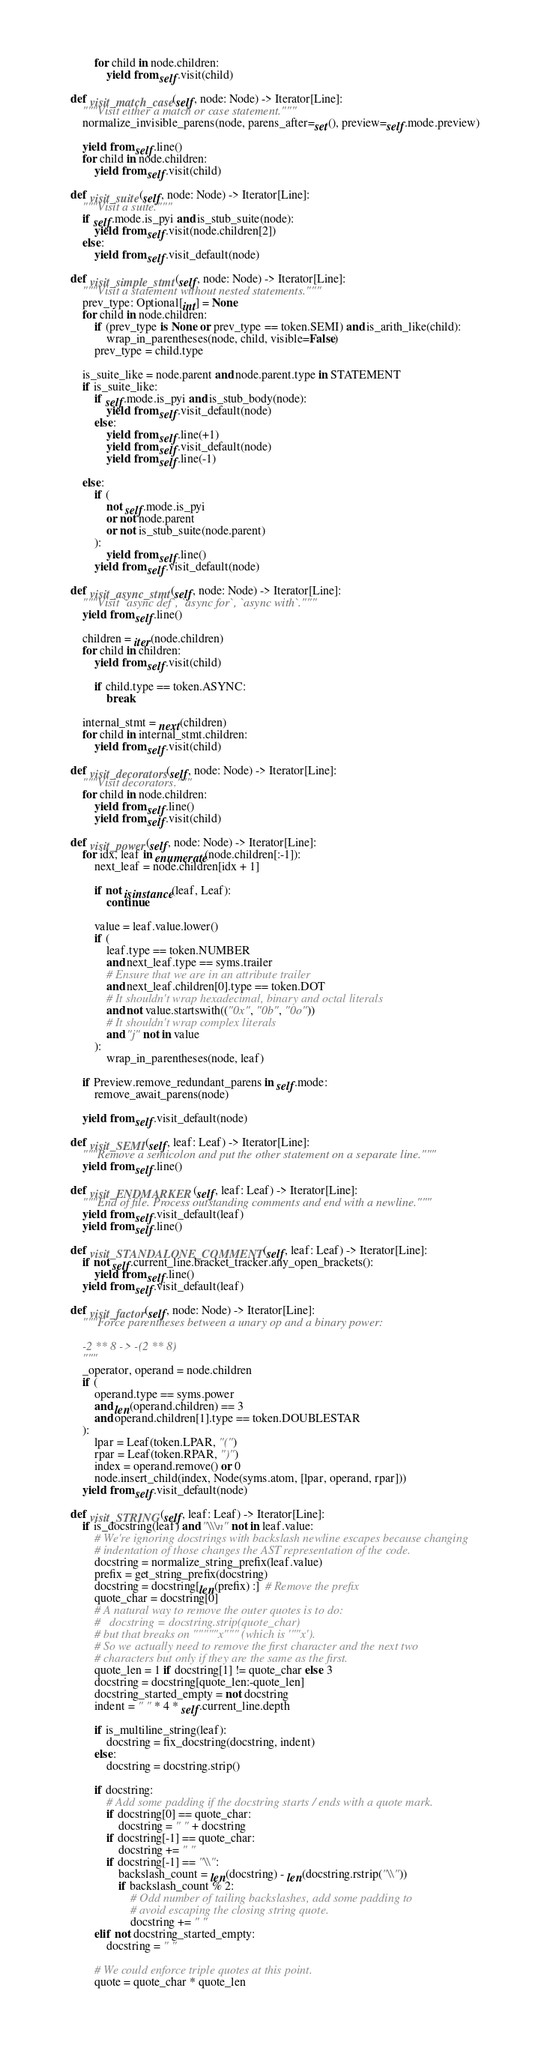Convert code to text. <code><loc_0><loc_0><loc_500><loc_500><_Python_>
            for child in node.children:
                yield from self.visit(child)

    def visit_match_case(self, node: Node) -> Iterator[Line]:
        """Visit either a match or case statement."""
        normalize_invisible_parens(node, parens_after=set(), preview=self.mode.preview)

        yield from self.line()
        for child in node.children:
            yield from self.visit(child)

    def visit_suite(self, node: Node) -> Iterator[Line]:
        """Visit a suite."""
        if self.mode.is_pyi and is_stub_suite(node):
            yield from self.visit(node.children[2])
        else:
            yield from self.visit_default(node)

    def visit_simple_stmt(self, node: Node) -> Iterator[Line]:
        """Visit a statement without nested statements."""
        prev_type: Optional[int] = None
        for child in node.children:
            if (prev_type is None or prev_type == token.SEMI) and is_arith_like(child):
                wrap_in_parentheses(node, child, visible=False)
            prev_type = child.type

        is_suite_like = node.parent and node.parent.type in STATEMENT
        if is_suite_like:
            if self.mode.is_pyi and is_stub_body(node):
                yield from self.visit_default(node)
            else:
                yield from self.line(+1)
                yield from self.visit_default(node)
                yield from self.line(-1)

        else:
            if (
                not self.mode.is_pyi
                or not node.parent
                or not is_stub_suite(node.parent)
            ):
                yield from self.line()
            yield from self.visit_default(node)

    def visit_async_stmt(self, node: Node) -> Iterator[Line]:
        """Visit `async def`, `async for`, `async with`."""
        yield from self.line()

        children = iter(node.children)
        for child in children:
            yield from self.visit(child)

            if child.type == token.ASYNC:
                break

        internal_stmt = next(children)
        for child in internal_stmt.children:
            yield from self.visit(child)

    def visit_decorators(self, node: Node) -> Iterator[Line]:
        """Visit decorators."""
        for child in node.children:
            yield from self.line()
            yield from self.visit(child)

    def visit_power(self, node: Node) -> Iterator[Line]:
        for idx, leaf in enumerate(node.children[:-1]):
            next_leaf = node.children[idx + 1]

            if not isinstance(leaf, Leaf):
                continue

            value = leaf.value.lower()
            if (
                leaf.type == token.NUMBER
                and next_leaf.type == syms.trailer
                # Ensure that we are in an attribute trailer
                and next_leaf.children[0].type == token.DOT
                # It shouldn't wrap hexadecimal, binary and octal literals
                and not value.startswith(("0x", "0b", "0o"))
                # It shouldn't wrap complex literals
                and "j" not in value
            ):
                wrap_in_parentheses(node, leaf)

        if Preview.remove_redundant_parens in self.mode:
            remove_await_parens(node)

        yield from self.visit_default(node)

    def visit_SEMI(self, leaf: Leaf) -> Iterator[Line]:
        """Remove a semicolon and put the other statement on a separate line."""
        yield from self.line()

    def visit_ENDMARKER(self, leaf: Leaf) -> Iterator[Line]:
        """End of file. Process outstanding comments and end with a newline."""
        yield from self.visit_default(leaf)
        yield from self.line()

    def visit_STANDALONE_COMMENT(self, leaf: Leaf) -> Iterator[Line]:
        if not self.current_line.bracket_tracker.any_open_brackets():
            yield from self.line()
        yield from self.visit_default(leaf)

    def visit_factor(self, node: Node) -> Iterator[Line]:
        """Force parentheses between a unary op and a binary power:

        -2 ** 8 -> -(2 ** 8)
        """
        _operator, operand = node.children
        if (
            operand.type == syms.power
            and len(operand.children) == 3
            and operand.children[1].type == token.DOUBLESTAR
        ):
            lpar = Leaf(token.LPAR, "(")
            rpar = Leaf(token.RPAR, ")")
            index = operand.remove() or 0
            node.insert_child(index, Node(syms.atom, [lpar, operand, rpar]))
        yield from self.visit_default(node)

    def visit_STRING(self, leaf: Leaf) -> Iterator[Line]:
        if is_docstring(leaf) and "\\\n" not in leaf.value:
            # We're ignoring docstrings with backslash newline escapes because changing
            # indentation of those changes the AST representation of the code.
            docstring = normalize_string_prefix(leaf.value)
            prefix = get_string_prefix(docstring)
            docstring = docstring[len(prefix) :]  # Remove the prefix
            quote_char = docstring[0]
            # A natural way to remove the outer quotes is to do:
            #   docstring = docstring.strip(quote_char)
            # but that breaks on """""x""" (which is '""x').
            # So we actually need to remove the first character and the next two
            # characters but only if they are the same as the first.
            quote_len = 1 if docstring[1] != quote_char else 3
            docstring = docstring[quote_len:-quote_len]
            docstring_started_empty = not docstring
            indent = " " * 4 * self.current_line.depth

            if is_multiline_string(leaf):
                docstring = fix_docstring(docstring, indent)
            else:
                docstring = docstring.strip()

            if docstring:
                # Add some padding if the docstring starts / ends with a quote mark.
                if docstring[0] == quote_char:
                    docstring = " " + docstring
                if docstring[-1] == quote_char:
                    docstring += " "
                if docstring[-1] == "\\":
                    backslash_count = len(docstring) - len(docstring.rstrip("\\"))
                    if backslash_count % 2:
                        # Odd number of tailing backslashes, add some padding to
                        # avoid escaping the closing string quote.
                        docstring += " "
            elif not docstring_started_empty:
                docstring = " "

            # We could enforce triple quotes at this point.
            quote = quote_char * quote_len
</code> 